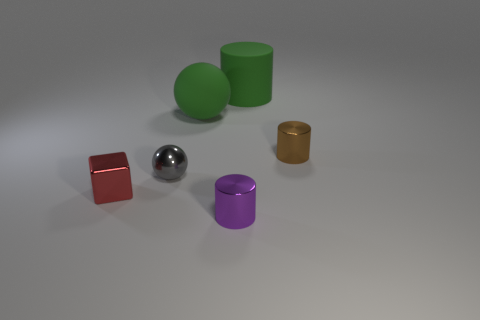There is a object that is on the left side of the shiny ball; does it have the same shape as the tiny brown object?
Your response must be concise. No. How many big cyan matte cubes are there?
Offer a very short reply. 0. What number of other brown cylinders are the same size as the brown cylinder?
Offer a terse response. 0. What material is the small brown cylinder?
Provide a short and direct response. Metal. There is a matte cylinder; does it have the same color as the rubber object on the left side of the tiny purple cylinder?
Offer a terse response. Yes. What size is the thing that is both right of the small gray thing and in front of the tiny metal ball?
Your answer should be very brief. Small. The green thing that is the same material as the green ball is what shape?
Offer a very short reply. Cylinder. Is the material of the gray object the same as the ball that is right of the small sphere?
Provide a succinct answer. No. There is a tiny cylinder to the left of the green rubber cylinder; are there any metal things behind it?
Ensure brevity in your answer.  Yes. What material is the small brown thing that is the same shape as the small purple thing?
Keep it short and to the point. Metal. 